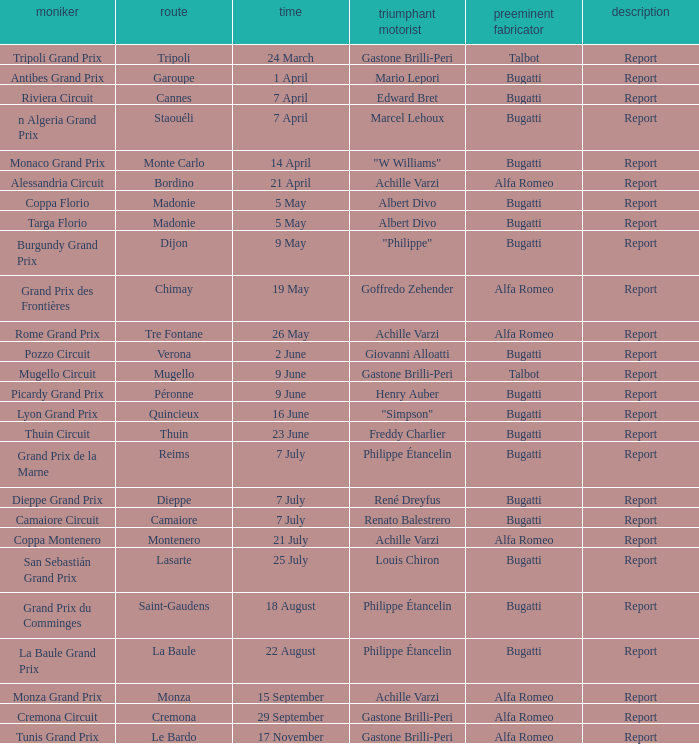What Circuit has a Winning constructor of bugatti, and a Winning driver of edward bret? Cannes. 